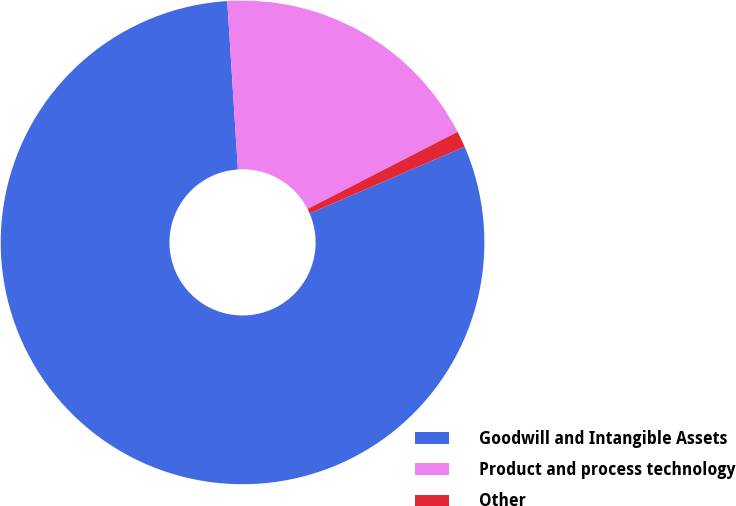Convert chart to OTSL. <chart><loc_0><loc_0><loc_500><loc_500><pie_chart><fcel>Goodwill and Intangible Assets<fcel>Product and process technology<fcel>Other<nl><fcel>80.47%<fcel>18.45%<fcel>1.08%<nl></chart> 